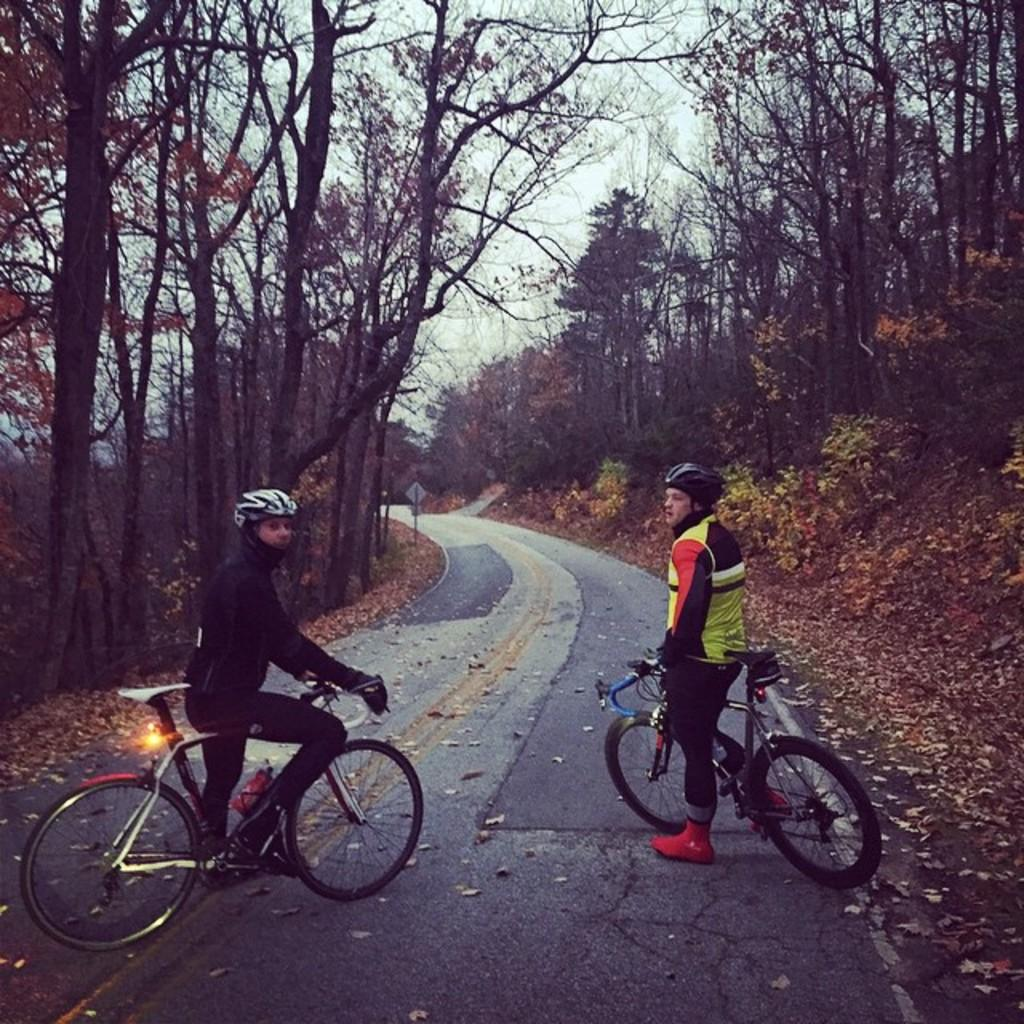How many people are in the image? There are two persons in the image. What are the persons doing in the image? Both persons are with cycles. Where are the persons located in the image? The persons are on the road. What can be seen in the background of the image? There are trees, plants, and a sign board in the background of the image. What type of cherry is being sold at the sign board in the image? There is no mention of cherries or any sign of a sign board selling cherries in the image. How many snails can be seen crawling on the road in the image? There are no snails visible on the road in the image. 